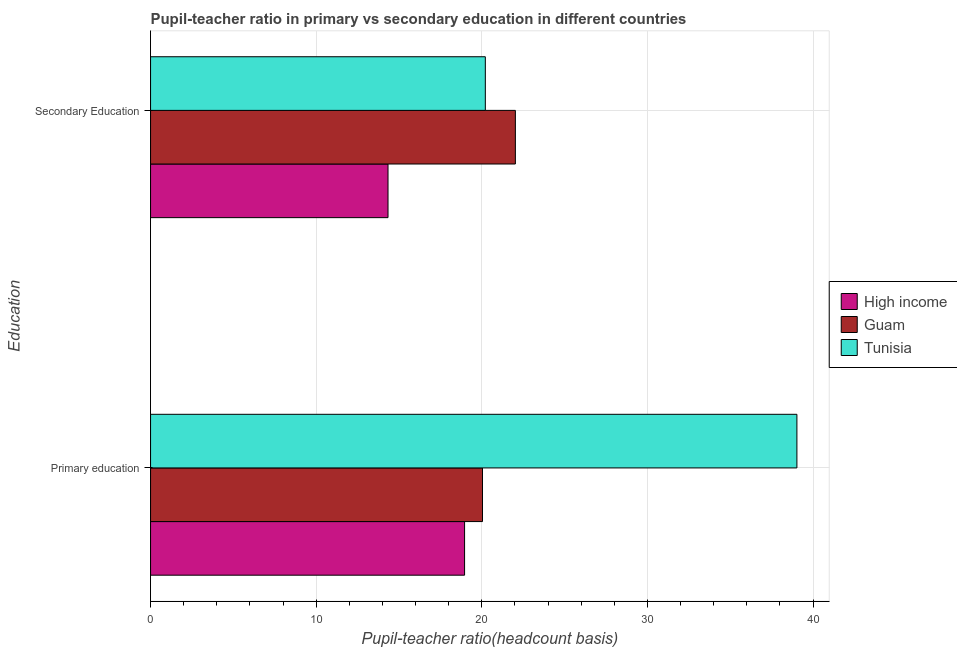How many different coloured bars are there?
Your answer should be very brief. 3. Are the number of bars per tick equal to the number of legend labels?
Keep it short and to the point. Yes. Are the number of bars on each tick of the Y-axis equal?
Provide a short and direct response. Yes. How many bars are there on the 1st tick from the top?
Offer a terse response. 3. What is the pupil teacher ratio on secondary education in Guam?
Keep it short and to the point. 22.03. Across all countries, what is the maximum pupil teacher ratio on secondary education?
Your answer should be compact. 22.03. Across all countries, what is the minimum pupil-teacher ratio in primary education?
Give a very brief answer. 18.96. In which country was the pupil-teacher ratio in primary education maximum?
Offer a very short reply. Tunisia. What is the total pupil teacher ratio on secondary education in the graph?
Ensure brevity in your answer.  56.57. What is the difference between the pupil-teacher ratio in primary education in Guam and that in High income?
Your response must be concise. 1.08. What is the difference between the pupil teacher ratio on secondary education in Guam and the pupil-teacher ratio in primary education in High income?
Give a very brief answer. 3.07. What is the average pupil-teacher ratio in primary education per country?
Keep it short and to the point. 26.01. What is the difference between the pupil-teacher ratio in primary education and pupil teacher ratio on secondary education in High income?
Offer a very short reply. 4.62. In how many countries, is the pupil-teacher ratio in primary education greater than 34 ?
Your response must be concise. 1. What is the ratio of the pupil teacher ratio on secondary education in High income to that in Tunisia?
Give a very brief answer. 0.71. Is the pupil-teacher ratio in primary education in Guam less than that in Tunisia?
Provide a short and direct response. Yes. What does the 3rd bar from the bottom in Primary education represents?
Offer a terse response. Tunisia. Are all the bars in the graph horizontal?
Ensure brevity in your answer.  Yes. Where does the legend appear in the graph?
Give a very brief answer. Center right. How many legend labels are there?
Provide a short and direct response. 3. What is the title of the graph?
Make the answer very short. Pupil-teacher ratio in primary vs secondary education in different countries. What is the label or title of the X-axis?
Offer a terse response. Pupil-teacher ratio(headcount basis). What is the label or title of the Y-axis?
Your answer should be compact. Education. What is the Pupil-teacher ratio(headcount basis) in High income in Primary education?
Your answer should be very brief. 18.96. What is the Pupil-teacher ratio(headcount basis) in Guam in Primary education?
Offer a very short reply. 20.04. What is the Pupil-teacher ratio(headcount basis) of Tunisia in Primary education?
Ensure brevity in your answer.  39.02. What is the Pupil-teacher ratio(headcount basis) of High income in Secondary Education?
Offer a very short reply. 14.34. What is the Pupil-teacher ratio(headcount basis) of Guam in Secondary Education?
Your answer should be compact. 22.03. What is the Pupil-teacher ratio(headcount basis) of Tunisia in Secondary Education?
Offer a very short reply. 20.21. Across all Education, what is the maximum Pupil-teacher ratio(headcount basis) of High income?
Offer a terse response. 18.96. Across all Education, what is the maximum Pupil-teacher ratio(headcount basis) in Guam?
Your answer should be very brief. 22.03. Across all Education, what is the maximum Pupil-teacher ratio(headcount basis) of Tunisia?
Your response must be concise. 39.02. Across all Education, what is the minimum Pupil-teacher ratio(headcount basis) in High income?
Keep it short and to the point. 14.34. Across all Education, what is the minimum Pupil-teacher ratio(headcount basis) of Guam?
Ensure brevity in your answer.  20.04. Across all Education, what is the minimum Pupil-teacher ratio(headcount basis) of Tunisia?
Your answer should be very brief. 20.21. What is the total Pupil-teacher ratio(headcount basis) of High income in the graph?
Your answer should be very brief. 33.3. What is the total Pupil-teacher ratio(headcount basis) in Guam in the graph?
Ensure brevity in your answer.  42.07. What is the total Pupil-teacher ratio(headcount basis) of Tunisia in the graph?
Provide a short and direct response. 59.24. What is the difference between the Pupil-teacher ratio(headcount basis) in High income in Primary education and that in Secondary Education?
Keep it short and to the point. 4.62. What is the difference between the Pupil-teacher ratio(headcount basis) in Guam in Primary education and that in Secondary Education?
Give a very brief answer. -1.98. What is the difference between the Pupil-teacher ratio(headcount basis) of Tunisia in Primary education and that in Secondary Education?
Offer a terse response. 18.81. What is the difference between the Pupil-teacher ratio(headcount basis) in High income in Primary education and the Pupil-teacher ratio(headcount basis) in Guam in Secondary Education?
Your answer should be very brief. -3.07. What is the difference between the Pupil-teacher ratio(headcount basis) in High income in Primary education and the Pupil-teacher ratio(headcount basis) in Tunisia in Secondary Education?
Your answer should be compact. -1.25. What is the difference between the Pupil-teacher ratio(headcount basis) in Guam in Primary education and the Pupil-teacher ratio(headcount basis) in Tunisia in Secondary Education?
Offer a terse response. -0.17. What is the average Pupil-teacher ratio(headcount basis) in High income per Education?
Provide a short and direct response. 16.65. What is the average Pupil-teacher ratio(headcount basis) of Guam per Education?
Make the answer very short. 21.03. What is the average Pupil-teacher ratio(headcount basis) of Tunisia per Education?
Ensure brevity in your answer.  29.62. What is the difference between the Pupil-teacher ratio(headcount basis) of High income and Pupil-teacher ratio(headcount basis) of Guam in Primary education?
Offer a very short reply. -1.08. What is the difference between the Pupil-teacher ratio(headcount basis) in High income and Pupil-teacher ratio(headcount basis) in Tunisia in Primary education?
Offer a terse response. -20.07. What is the difference between the Pupil-teacher ratio(headcount basis) in Guam and Pupil-teacher ratio(headcount basis) in Tunisia in Primary education?
Your answer should be very brief. -18.98. What is the difference between the Pupil-teacher ratio(headcount basis) of High income and Pupil-teacher ratio(headcount basis) of Guam in Secondary Education?
Give a very brief answer. -7.69. What is the difference between the Pupil-teacher ratio(headcount basis) in High income and Pupil-teacher ratio(headcount basis) in Tunisia in Secondary Education?
Provide a succinct answer. -5.88. What is the difference between the Pupil-teacher ratio(headcount basis) in Guam and Pupil-teacher ratio(headcount basis) in Tunisia in Secondary Education?
Offer a very short reply. 1.81. What is the ratio of the Pupil-teacher ratio(headcount basis) in High income in Primary education to that in Secondary Education?
Provide a short and direct response. 1.32. What is the ratio of the Pupil-teacher ratio(headcount basis) in Guam in Primary education to that in Secondary Education?
Your answer should be compact. 0.91. What is the ratio of the Pupil-teacher ratio(headcount basis) of Tunisia in Primary education to that in Secondary Education?
Provide a short and direct response. 1.93. What is the difference between the highest and the second highest Pupil-teacher ratio(headcount basis) in High income?
Your response must be concise. 4.62. What is the difference between the highest and the second highest Pupil-teacher ratio(headcount basis) in Guam?
Offer a very short reply. 1.98. What is the difference between the highest and the second highest Pupil-teacher ratio(headcount basis) of Tunisia?
Your response must be concise. 18.81. What is the difference between the highest and the lowest Pupil-teacher ratio(headcount basis) in High income?
Ensure brevity in your answer.  4.62. What is the difference between the highest and the lowest Pupil-teacher ratio(headcount basis) in Guam?
Offer a very short reply. 1.98. What is the difference between the highest and the lowest Pupil-teacher ratio(headcount basis) in Tunisia?
Your answer should be compact. 18.81. 